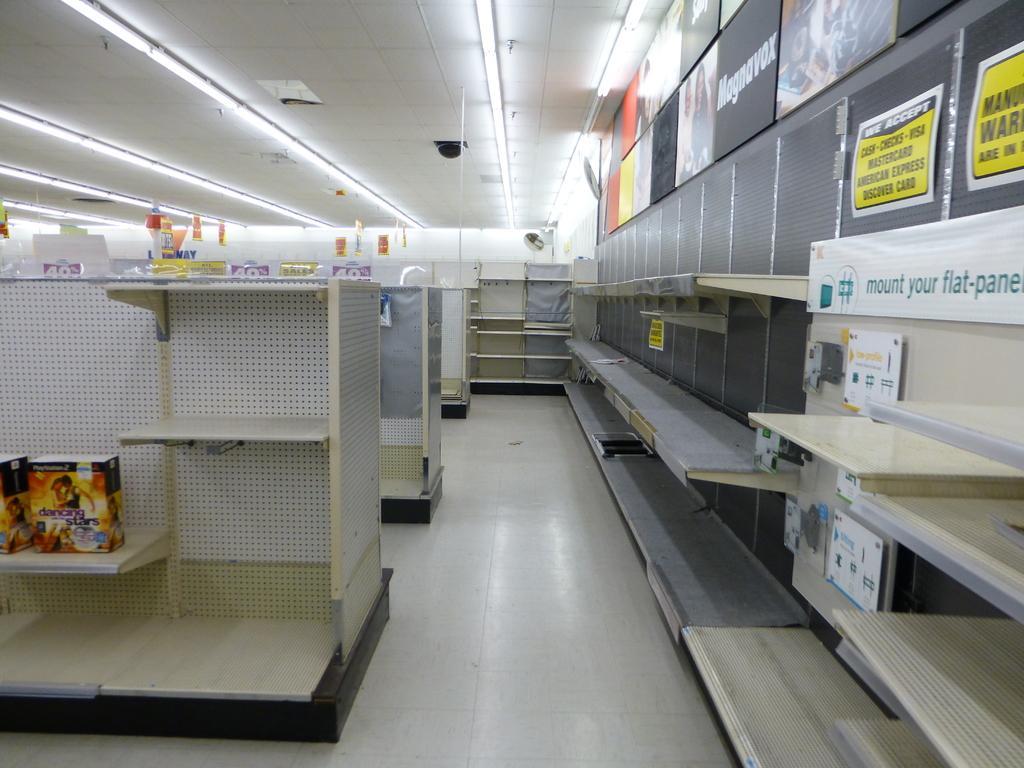Could you give a brief overview of what you see in this image? In this image we can see cupboards and some objects are placed here. Here we can see the banners and the ceiling lights in the background. 